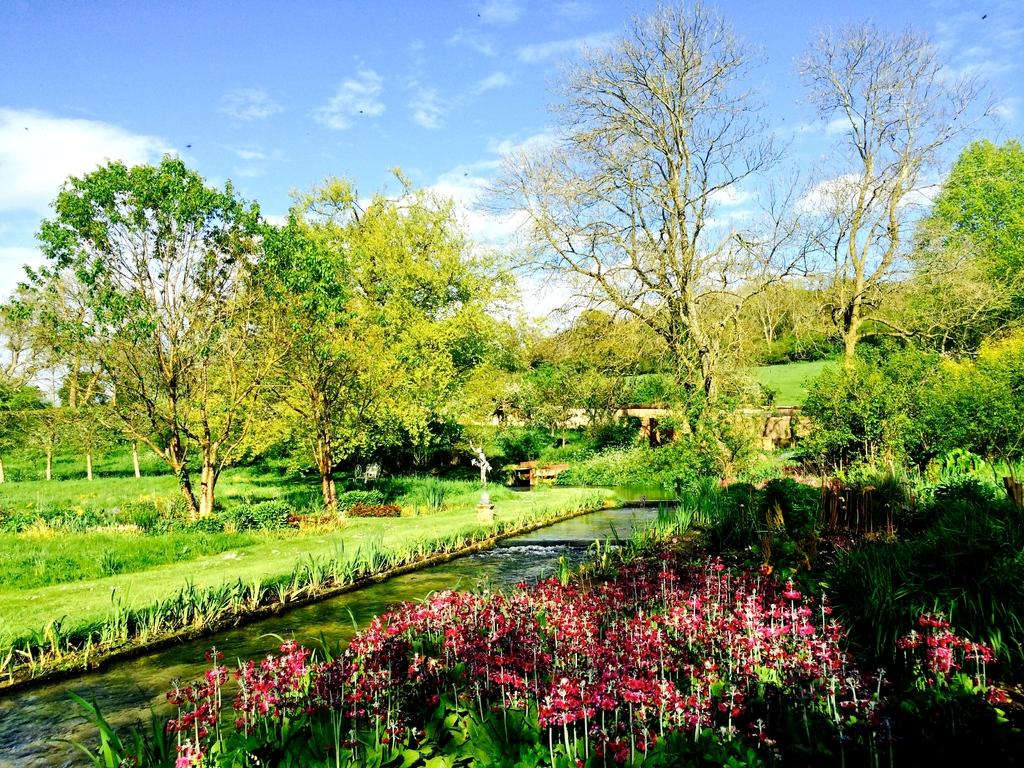What type of vegetation can be seen in the image? There are trees, plants, and flowers in the image. What structure is present in the image? There is a bridge in the image. What can be seen in the sky in the image? There are clouds in the sky in the image. What is visible at the bottom of the image? There is water visible at the bottom of the image. Where are the shoes placed in the image? There are no shoes present in the image. What type of vein can be seen in the image? There are no veins present in the image; it features natural elements such as trees, plants, flowers, a bridge, clouds, and water. 